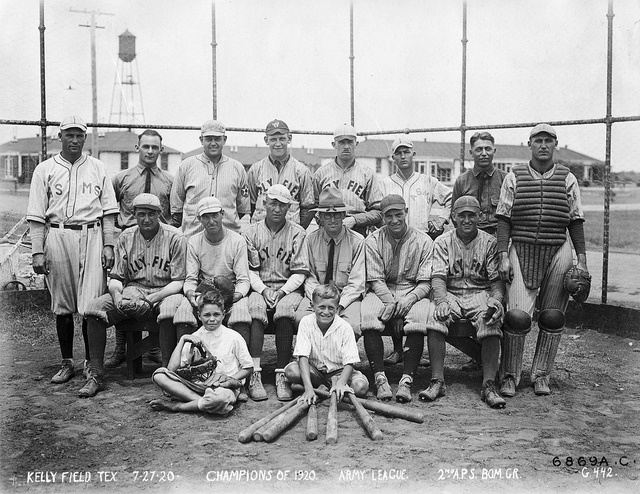Describe the objects in this image and their specific colors. I can see people in white, lightgray, darkgray, gray, and black tones, people in white, black, gray, darkgray, and lightgray tones, people in white, lightgray, darkgray, gray, and black tones, people in white, darkgray, black, gray, and lightgray tones, and people in white, gray, black, darkgray, and lightgray tones in this image. 